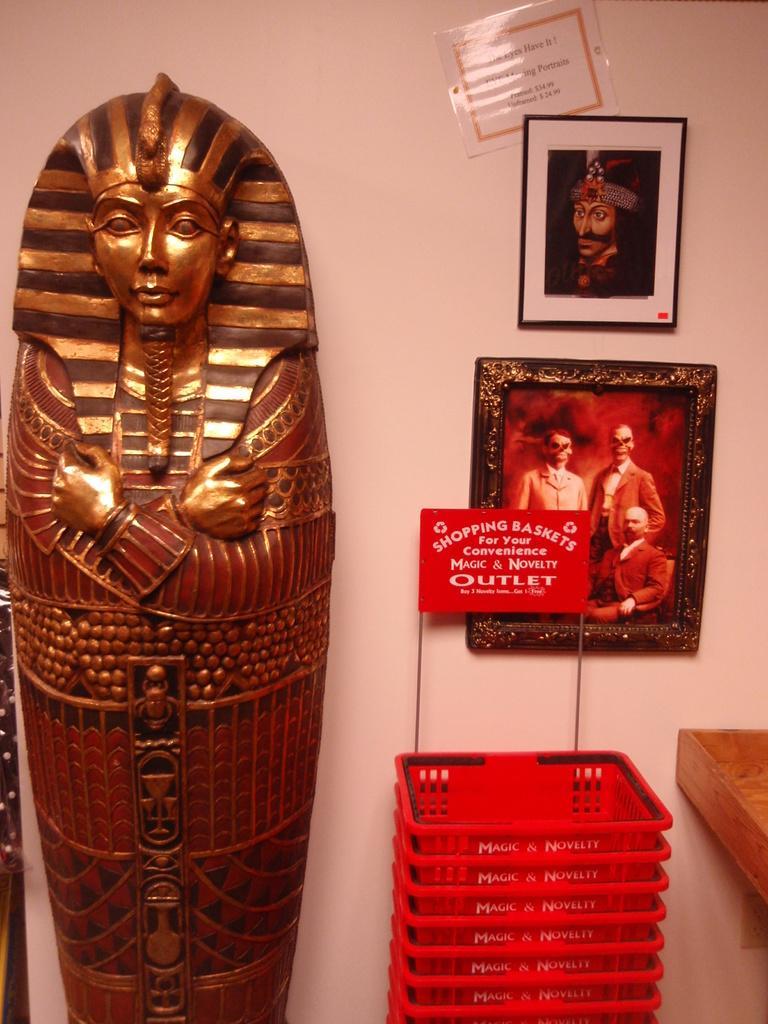How would you summarize this image in a sentence or two? In the picture there is a statue, beside the statue there are shopping baskets present, there is a wall, on the wall there are statues present. 